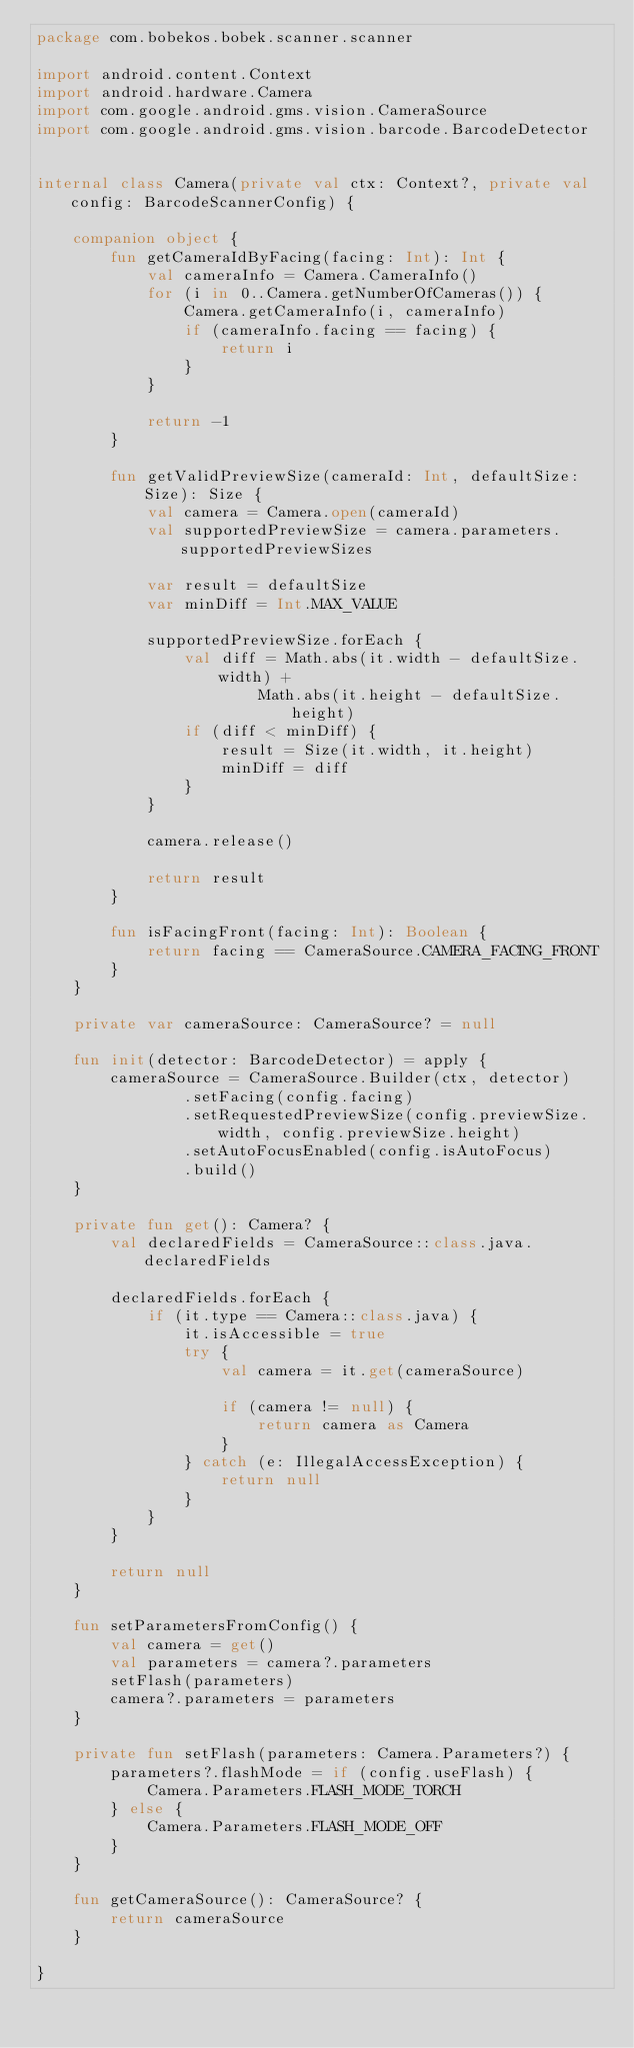Convert code to text. <code><loc_0><loc_0><loc_500><loc_500><_Kotlin_>package com.bobekos.bobek.scanner.scanner

import android.content.Context
import android.hardware.Camera
import com.google.android.gms.vision.CameraSource
import com.google.android.gms.vision.barcode.BarcodeDetector


internal class Camera(private val ctx: Context?, private val config: BarcodeScannerConfig) {

    companion object {
        fun getCameraIdByFacing(facing: Int): Int {
            val cameraInfo = Camera.CameraInfo()
            for (i in 0..Camera.getNumberOfCameras()) {
                Camera.getCameraInfo(i, cameraInfo)
                if (cameraInfo.facing == facing) {
                    return i
                }
            }

            return -1
        }

        fun getValidPreviewSize(cameraId: Int, defaultSize: Size): Size {
            val camera = Camera.open(cameraId)
            val supportedPreviewSize = camera.parameters.supportedPreviewSizes

            var result = defaultSize
            var minDiff = Int.MAX_VALUE

            supportedPreviewSize.forEach {
                val diff = Math.abs(it.width - defaultSize.width) +
                        Math.abs(it.height - defaultSize.height)
                if (diff < minDiff) {
                    result = Size(it.width, it.height)
                    minDiff = diff
                }
            }

            camera.release()

            return result
        }

        fun isFacingFront(facing: Int): Boolean {
            return facing == CameraSource.CAMERA_FACING_FRONT
        }
    }

    private var cameraSource: CameraSource? = null

    fun init(detector: BarcodeDetector) = apply {
        cameraSource = CameraSource.Builder(ctx, detector)
                .setFacing(config.facing)
                .setRequestedPreviewSize(config.previewSize.width, config.previewSize.height)
                .setAutoFocusEnabled(config.isAutoFocus)
                .build()
    }

    private fun get(): Camera? {
        val declaredFields = CameraSource::class.java.declaredFields

        declaredFields.forEach {
            if (it.type == Camera::class.java) {
                it.isAccessible = true
                try {
                    val camera = it.get(cameraSource)

                    if (camera != null) {
                        return camera as Camera
                    }
                } catch (e: IllegalAccessException) {
                    return null
                }
            }
        }

        return null
    }

    fun setParametersFromConfig() {
        val camera = get()
        val parameters = camera?.parameters
        setFlash(parameters)
        camera?.parameters = parameters
    }

    private fun setFlash(parameters: Camera.Parameters?) {
        parameters?.flashMode = if (config.useFlash) {
            Camera.Parameters.FLASH_MODE_TORCH
        } else {
            Camera.Parameters.FLASH_MODE_OFF
        }
    }

    fun getCameraSource(): CameraSource? {
        return cameraSource
    }

}</code> 